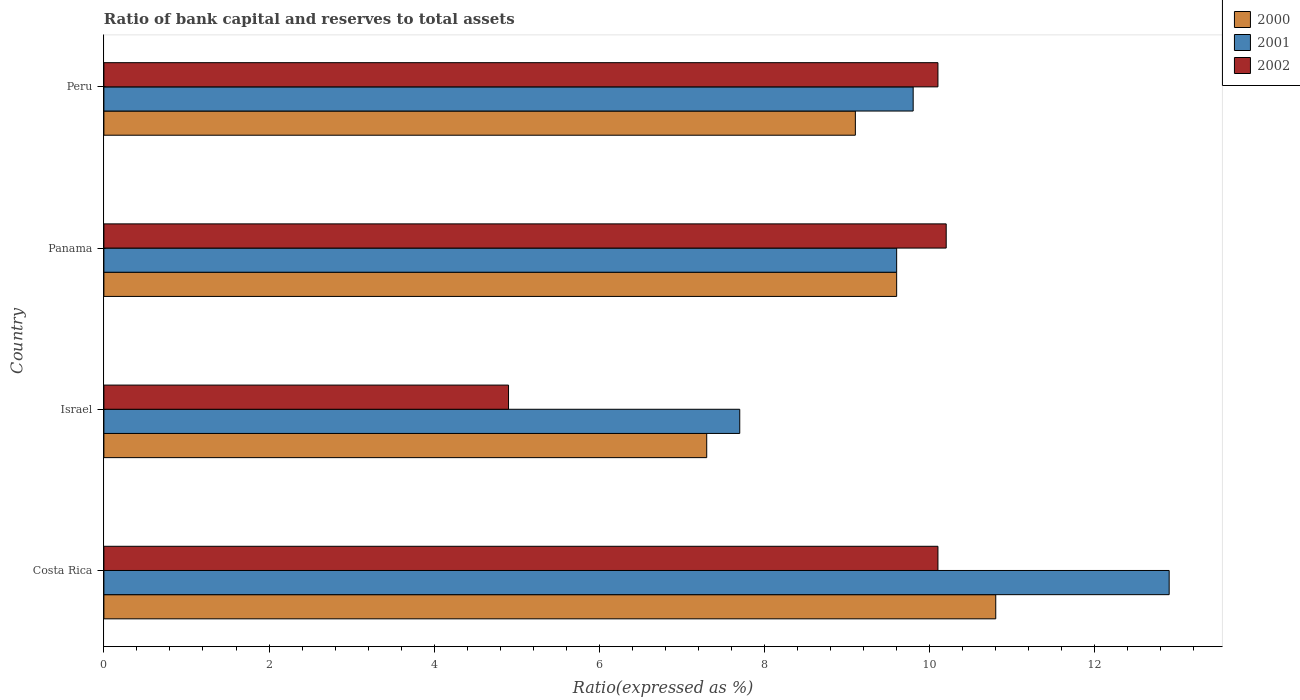How many groups of bars are there?
Offer a terse response. 4. How many bars are there on the 3rd tick from the bottom?
Provide a short and direct response. 3. What is the label of the 1st group of bars from the top?
Your response must be concise. Peru. In how many cases, is the number of bars for a given country not equal to the number of legend labels?
Offer a terse response. 0. What is the ratio of bank capital and reserves to total assets in 2002 in Panama?
Your answer should be very brief. 10.2. Across all countries, what is the maximum ratio of bank capital and reserves to total assets in 2002?
Provide a succinct answer. 10.2. Across all countries, what is the minimum ratio of bank capital and reserves to total assets in 2002?
Keep it short and to the point. 4.9. In which country was the ratio of bank capital and reserves to total assets in 2002 maximum?
Your response must be concise. Panama. In which country was the ratio of bank capital and reserves to total assets in 2000 minimum?
Your answer should be very brief. Israel. What is the total ratio of bank capital and reserves to total assets in 2001 in the graph?
Your answer should be compact. 40. What is the difference between the ratio of bank capital and reserves to total assets in 2001 in Costa Rica and that in Peru?
Provide a short and direct response. 3.1. What is the difference between the ratio of bank capital and reserves to total assets in 2001 in Israel and the ratio of bank capital and reserves to total assets in 2000 in Costa Rica?
Your response must be concise. -3.1. What is the average ratio of bank capital and reserves to total assets in 2000 per country?
Offer a very short reply. 9.2. What is the difference between the ratio of bank capital and reserves to total assets in 2002 and ratio of bank capital and reserves to total assets in 2000 in Panama?
Provide a short and direct response. 0.6. What is the ratio of the ratio of bank capital and reserves to total assets in 2000 in Israel to that in Peru?
Your answer should be very brief. 0.8. Is the ratio of bank capital and reserves to total assets in 2001 in Costa Rica less than that in Peru?
Provide a short and direct response. No. Is the difference between the ratio of bank capital and reserves to total assets in 2002 in Panama and Peru greater than the difference between the ratio of bank capital and reserves to total assets in 2000 in Panama and Peru?
Provide a short and direct response. No. What is the difference between the highest and the second highest ratio of bank capital and reserves to total assets in 2000?
Your answer should be compact. 1.2. Is the sum of the ratio of bank capital and reserves to total assets in 2002 in Costa Rica and Israel greater than the maximum ratio of bank capital and reserves to total assets in 2000 across all countries?
Your answer should be compact. Yes. What does the 3rd bar from the top in Peru represents?
Make the answer very short. 2000. What is the difference between two consecutive major ticks on the X-axis?
Make the answer very short. 2. Are the values on the major ticks of X-axis written in scientific E-notation?
Provide a short and direct response. No. Where does the legend appear in the graph?
Provide a short and direct response. Top right. How many legend labels are there?
Offer a terse response. 3. What is the title of the graph?
Your answer should be compact. Ratio of bank capital and reserves to total assets. Does "1993" appear as one of the legend labels in the graph?
Make the answer very short. No. What is the label or title of the X-axis?
Ensure brevity in your answer.  Ratio(expressed as %). What is the Ratio(expressed as %) of 2000 in Costa Rica?
Keep it short and to the point. 10.8. What is the Ratio(expressed as %) in 2002 in Costa Rica?
Provide a short and direct response. 10.1. What is the Ratio(expressed as %) of 2000 in Israel?
Offer a terse response. 7.3. What is the Ratio(expressed as %) in 2002 in Israel?
Provide a short and direct response. 4.9. What is the Ratio(expressed as %) of 2000 in Panama?
Provide a short and direct response. 9.6. What is the Ratio(expressed as %) in 2001 in Panama?
Offer a very short reply. 9.6. What is the Ratio(expressed as %) of 2000 in Peru?
Give a very brief answer. 9.1. What is the Ratio(expressed as %) of 2002 in Peru?
Make the answer very short. 10.1. Across all countries, what is the maximum Ratio(expressed as %) of 2000?
Provide a short and direct response. 10.8. What is the total Ratio(expressed as %) of 2000 in the graph?
Provide a succinct answer. 36.8. What is the total Ratio(expressed as %) of 2001 in the graph?
Offer a terse response. 40. What is the total Ratio(expressed as %) of 2002 in the graph?
Your answer should be very brief. 35.3. What is the difference between the Ratio(expressed as %) of 2001 in Costa Rica and that in Panama?
Your answer should be very brief. 3.3. What is the difference between the Ratio(expressed as %) in 2001 in Costa Rica and that in Peru?
Your answer should be very brief. 3.1. What is the difference between the Ratio(expressed as %) of 2002 in Costa Rica and that in Peru?
Your answer should be compact. 0. What is the difference between the Ratio(expressed as %) in 2002 in Israel and that in Panama?
Provide a succinct answer. -5.3. What is the difference between the Ratio(expressed as %) in 2002 in Israel and that in Peru?
Ensure brevity in your answer.  -5.2. What is the difference between the Ratio(expressed as %) of 2000 in Panama and that in Peru?
Provide a short and direct response. 0.5. What is the difference between the Ratio(expressed as %) in 2001 in Panama and that in Peru?
Provide a short and direct response. -0.2. What is the difference between the Ratio(expressed as %) in 2001 in Costa Rica and the Ratio(expressed as %) in 2002 in Israel?
Your answer should be very brief. 8. What is the difference between the Ratio(expressed as %) in 2000 in Costa Rica and the Ratio(expressed as %) in 2001 in Panama?
Provide a succinct answer. 1.2. What is the difference between the Ratio(expressed as %) of 2001 in Costa Rica and the Ratio(expressed as %) of 2002 in Panama?
Your response must be concise. 2.7. What is the difference between the Ratio(expressed as %) of 2000 in Israel and the Ratio(expressed as %) of 2001 in Panama?
Give a very brief answer. -2.3. What is the difference between the Ratio(expressed as %) in 2000 in Israel and the Ratio(expressed as %) in 2002 in Panama?
Give a very brief answer. -2.9. What is the average Ratio(expressed as %) in 2000 per country?
Offer a terse response. 9.2. What is the average Ratio(expressed as %) in 2002 per country?
Provide a short and direct response. 8.82. What is the difference between the Ratio(expressed as %) in 2000 and Ratio(expressed as %) in 2002 in Costa Rica?
Offer a very short reply. 0.7. What is the difference between the Ratio(expressed as %) of 2001 and Ratio(expressed as %) of 2002 in Costa Rica?
Provide a short and direct response. 2.8. What is the difference between the Ratio(expressed as %) of 2000 and Ratio(expressed as %) of 2001 in Israel?
Make the answer very short. -0.4. What is the difference between the Ratio(expressed as %) in 2000 and Ratio(expressed as %) in 2002 in Israel?
Your response must be concise. 2.4. What is the difference between the Ratio(expressed as %) in 2001 and Ratio(expressed as %) in 2002 in Israel?
Ensure brevity in your answer.  2.8. What is the difference between the Ratio(expressed as %) of 2000 and Ratio(expressed as %) of 2001 in Panama?
Make the answer very short. 0. What is the difference between the Ratio(expressed as %) of 2001 and Ratio(expressed as %) of 2002 in Panama?
Provide a succinct answer. -0.6. What is the difference between the Ratio(expressed as %) of 2000 and Ratio(expressed as %) of 2001 in Peru?
Your answer should be compact. -0.7. What is the difference between the Ratio(expressed as %) of 2000 and Ratio(expressed as %) of 2002 in Peru?
Offer a very short reply. -1. What is the difference between the Ratio(expressed as %) of 2001 and Ratio(expressed as %) of 2002 in Peru?
Your answer should be very brief. -0.3. What is the ratio of the Ratio(expressed as %) in 2000 in Costa Rica to that in Israel?
Provide a succinct answer. 1.48. What is the ratio of the Ratio(expressed as %) of 2001 in Costa Rica to that in Israel?
Your answer should be very brief. 1.68. What is the ratio of the Ratio(expressed as %) in 2002 in Costa Rica to that in Israel?
Give a very brief answer. 2.06. What is the ratio of the Ratio(expressed as %) in 2000 in Costa Rica to that in Panama?
Give a very brief answer. 1.12. What is the ratio of the Ratio(expressed as %) in 2001 in Costa Rica to that in Panama?
Your response must be concise. 1.34. What is the ratio of the Ratio(expressed as %) of 2002 in Costa Rica to that in Panama?
Ensure brevity in your answer.  0.99. What is the ratio of the Ratio(expressed as %) in 2000 in Costa Rica to that in Peru?
Provide a short and direct response. 1.19. What is the ratio of the Ratio(expressed as %) of 2001 in Costa Rica to that in Peru?
Provide a short and direct response. 1.32. What is the ratio of the Ratio(expressed as %) in 2000 in Israel to that in Panama?
Provide a short and direct response. 0.76. What is the ratio of the Ratio(expressed as %) in 2001 in Israel to that in Panama?
Make the answer very short. 0.8. What is the ratio of the Ratio(expressed as %) in 2002 in Israel to that in Panama?
Your answer should be compact. 0.48. What is the ratio of the Ratio(expressed as %) in 2000 in Israel to that in Peru?
Your answer should be compact. 0.8. What is the ratio of the Ratio(expressed as %) of 2001 in Israel to that in Peru?
Ensure brevity in your answer.  0.79. What is the ratio of the Ratio(expressed as %) of 2002 in Israel to that in Peru?
Your answer should be very brief. 0.49. What is the ratio of the Ratio(expressed as %) of 2000 in Panama to that in Peru?
Your answer should be compact. 1.05. What is the ratio of the Ratio(expressed as %) in 2001 in Panama to that in Peru?
Your answer should be compact. 0.98. What is the ratio of the Ratio(expressed as %) of 2002 in Panama to that in Peru?
Your answer should be compact. 1.01. What is the difference between the highest and the second highest Ratio(expressed as %) of 2001?
Your answer should be very brief. 3.1. What is the difference between the highest and the lowest Ratio(expressed as %) in 2000?
Ensure brevity in your answer.  3.5. What is the difference between the highest and the lowest Ratio(expressed as %) of 2002?
Make the answer very short. 5.3. 